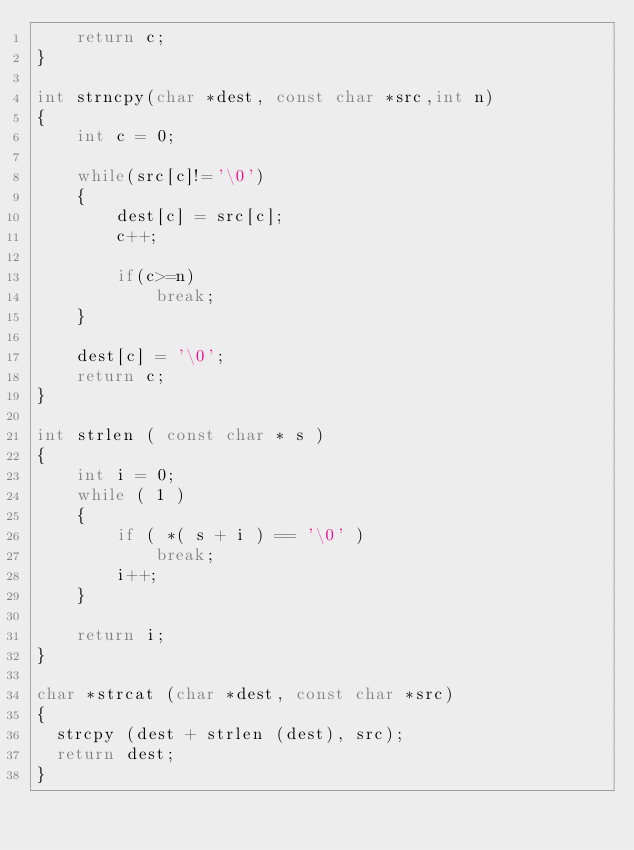<code> <loc_0><loc_0><loc_500><loc_500><_C_>    return c;
}

int strncpy(char *dest, const char *src,int n)
{
    int c = 0;

    while(src[c]!='\0')
    {
        dest[c] = src[c];
        c++;

        if(c>=n)
            break;
    }

    dest[c] = '\0';
    return c;
}

int strlen ( const char * s )
{
    int i = 0;
    while ( 1 )
    {
        if ( *( s + i ) == '\0' )
            break;
        i++;
    }

    return i;
}

char *strcat (char *dest, const char *src)
{
  strcpy (dest + strlen (dest), src);
  return dest;
}
</code> 